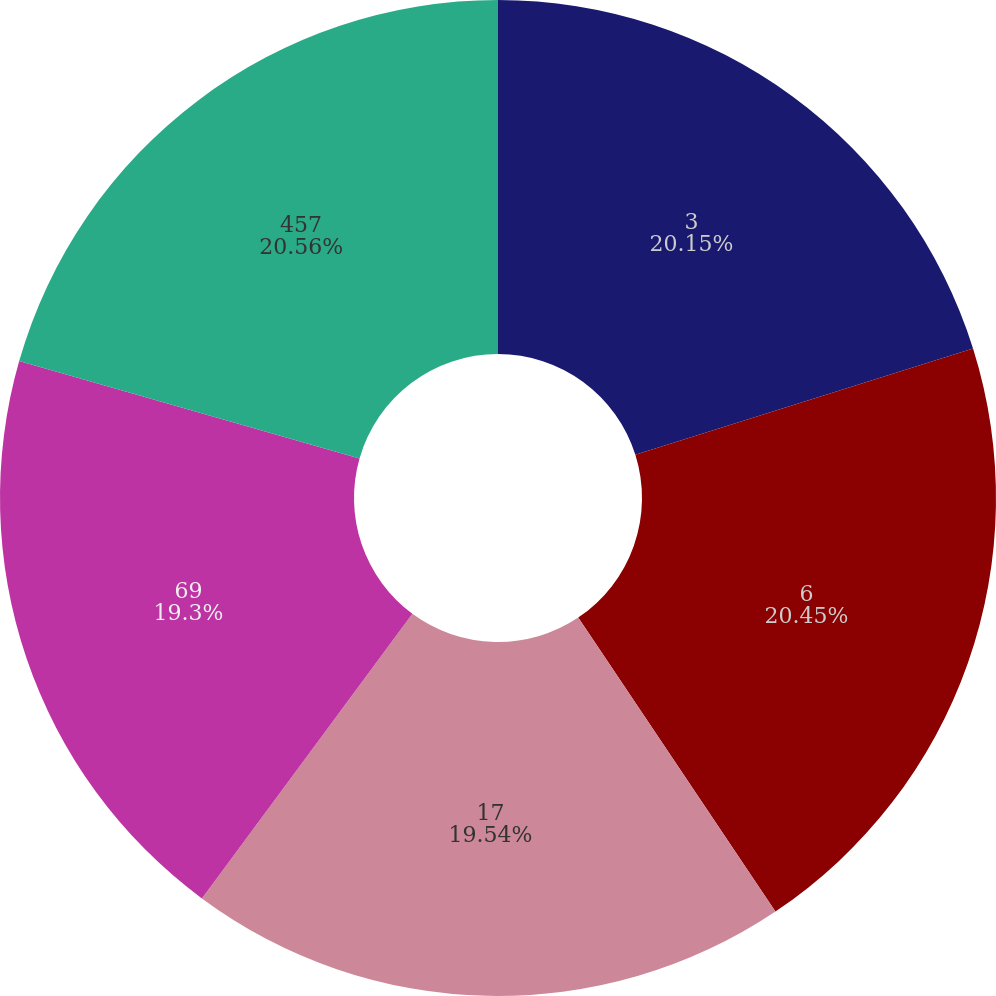Convert chart to OTSL. <chart><loc_0><loc_0><loc_500><loc_500><pie_chart><fcel>3<fcel>6<fcel>17<fcel>69<fcel>457<nl><fcel>20.15%<fcel>20.45%<fcel>19.54%<fcel>19.3%<fcel>20.57%<nl></chart> 